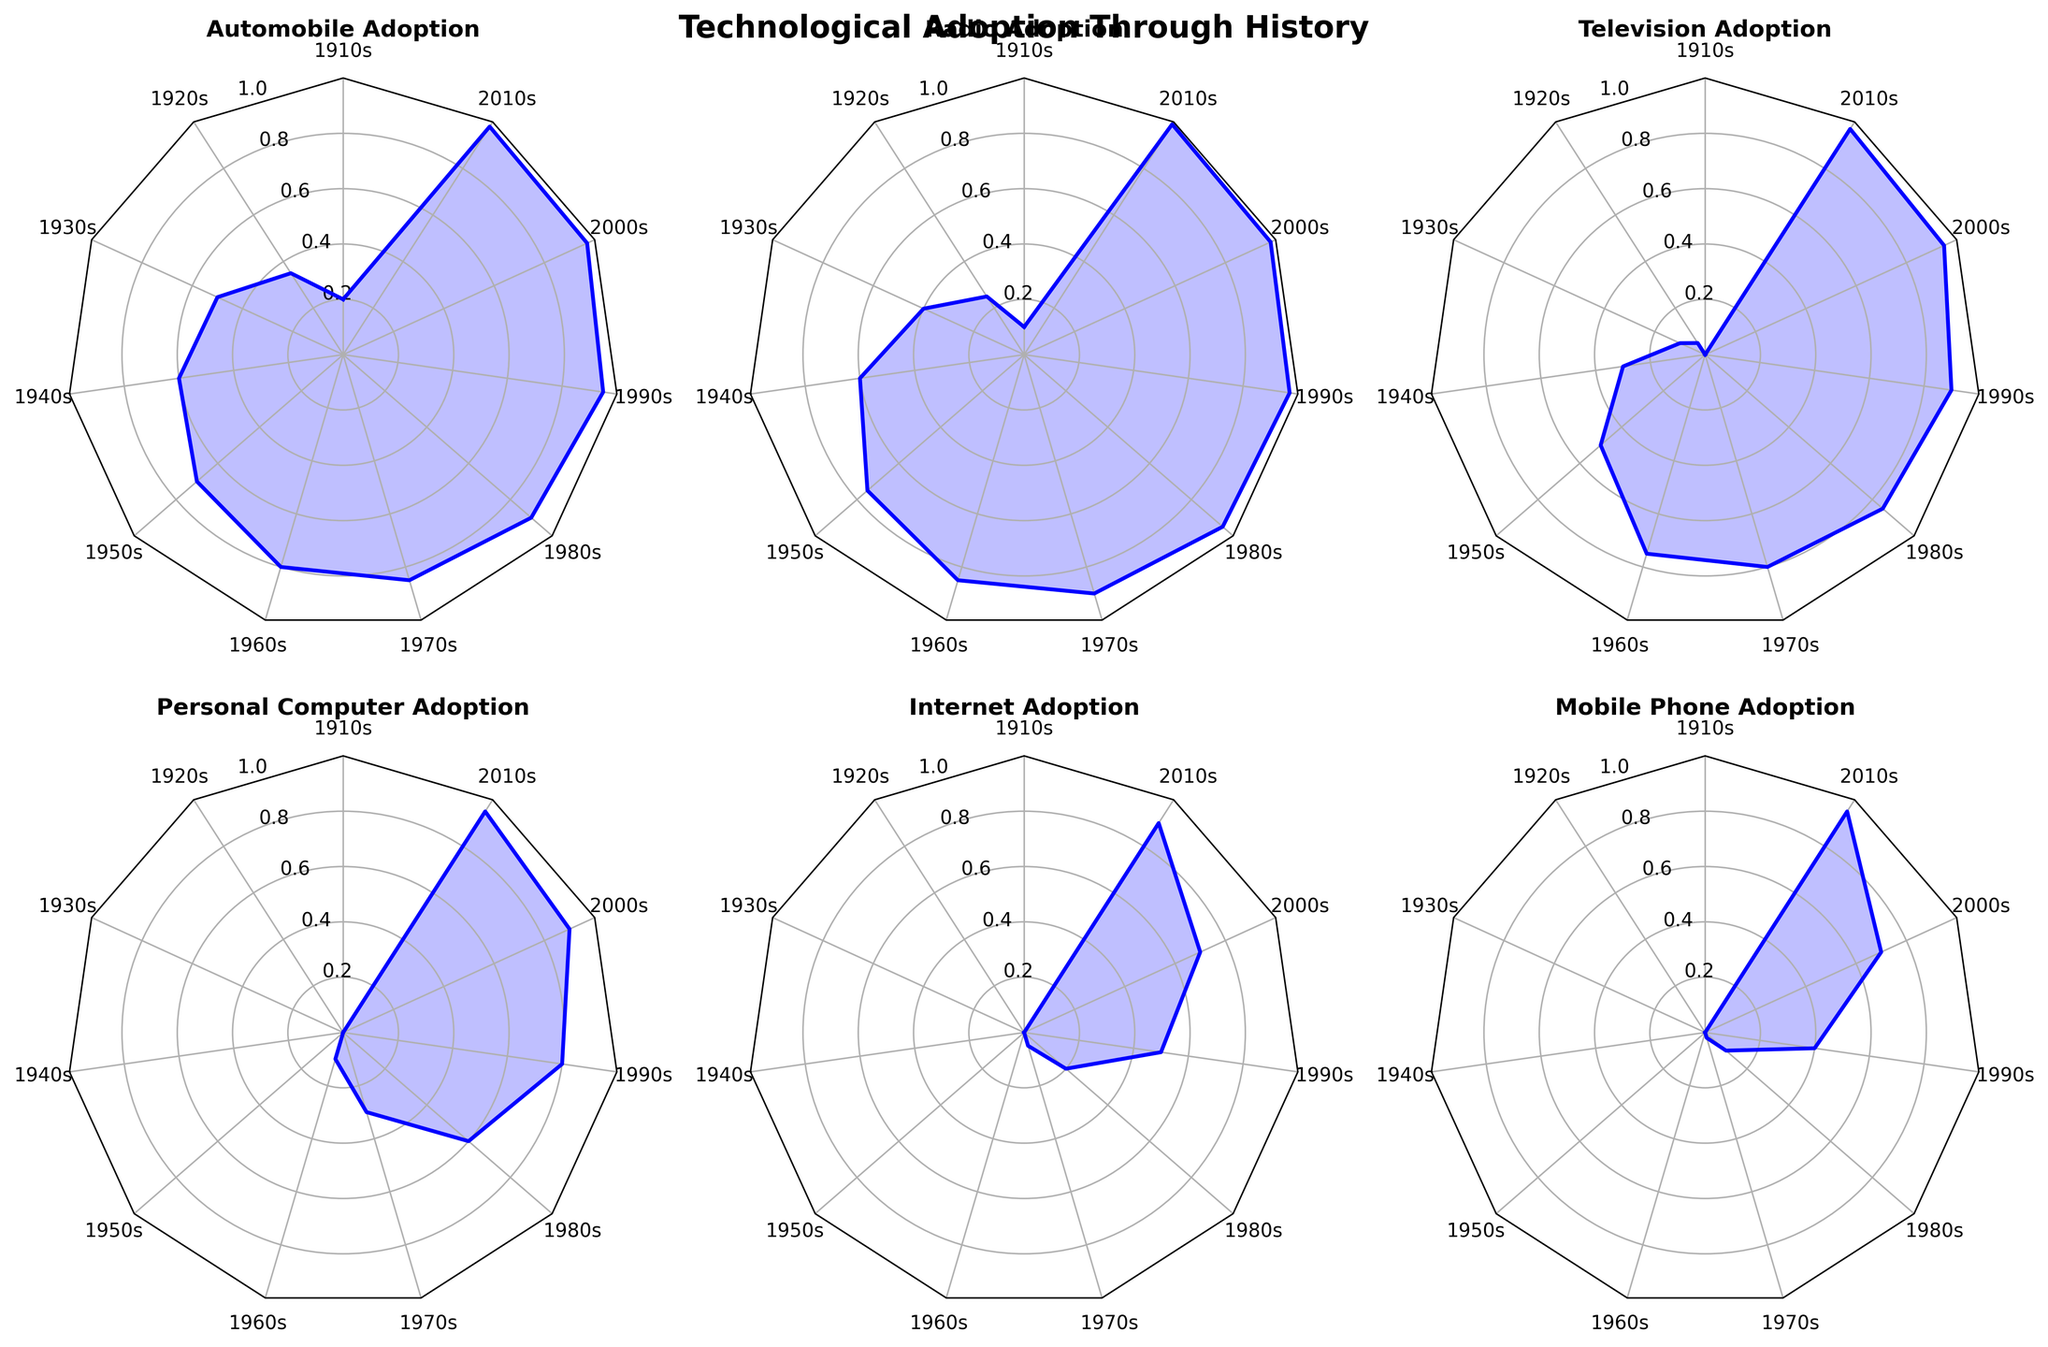What technological innovation had the highest adoption rate in the 2010s? To find the technological innovation with the highest adoption rate in the 2010s, check the end points of each subplot for the highest value. Internet and Mobile Phone Adoption both reach 0.95.
Answer: Internet and Mobile Phone Adoption Which decade saw the most significant increase in television adoption? Compare the increase in the adoption rate of televisions across each decade. The increase from the 1940s (0.3) to the 1950s (0.5) is the most significant jump (0.2).
Answer: 1940s to 1950s What is the overall trend in personal computer adoption from the 1960s to the 2010s? Trace the personal computer adoption rates from 1960s (0.1) through each subsequent decade. The trend shows a steady increase, reaching 0.95 in the 2010s.
Answer: Increasing Which technological innovation started adopting the earliest? Look at the starting point of each subplot. The automobile has the earliest adoption with a rate of 0.2 in the 1910s.
Answer: Automobile Which technological innovation had the lowest adoption rate in the 1970s? Compare the values for each innovation in the 1970s. The Mobile Phone Adoption is the lowest at 0.02.
Answer: Mobile Phone Adoption How did the adoption rate of the radio change from the 1910s to the 1920s? Compare the value of radio adoption in the 1910s (0.1) and the 1920s (0.25). There is an increase of 0.15.
Answer: Increased by 0.15 By how much did Internet adoption increase from the 1980s to the 1990s? Subtract the Internet adoption rate in the 1980s (0.05) from the rate in the 1990s (0.5). The increase is 0.45.
Answer: 0.45 Which technological innovation experienced the fastest initial adoption within two decades of starting? Check the adoption rate within the first two decades for each innovation. Internet increased from 0 (1980s) to 0.5 (1990s); a 0.5 rise in two decades.
Answer: Internet What was the difference in adoption rates of mobile phones and personal computers in the 2000s? Compare mobile phone adoption (0.7) and personal computer adoption (0.9) in the 2000s. The difference is 0.2.
Answer: 0.2 Which technology reached above 90% adoption the earliest? Identify which subplot first exceeds 0.9. The radio reached 0.95 in the 1980s.
Answer: Radio 